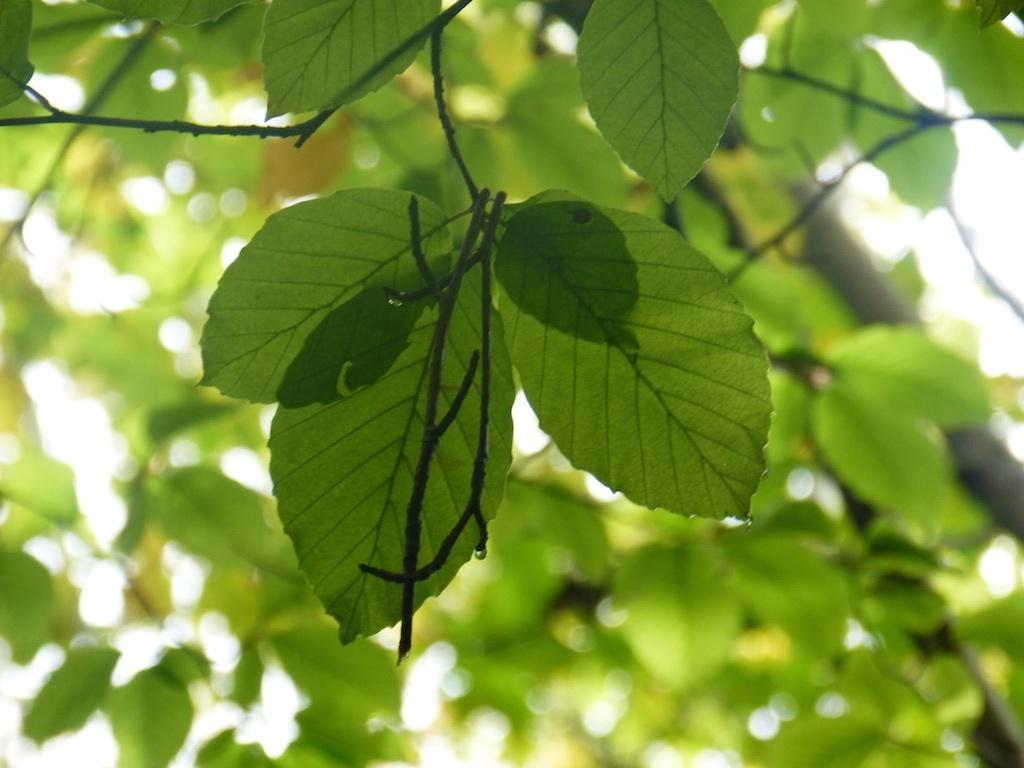What type of vegetation can be seen in the image? There are trees in the image. What part of the natural environment is visible in the image? The sky is visible in the image. Based on the visibility of the sky and trees, can you infer the time of day the image was taken? The image was likely taken during the day, as the sky is visible and the trees are well-lit. Can you see any toes in the image? There are no toes visible in the image. Is there a cup of tea being served in the image? There is no cup of tea or any other beverage present in the image. 